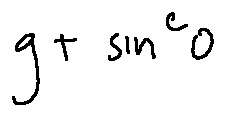<formula> <loc_0><loc_0><loc_500><loc_500>g + \sin ^ { c } o</formula> 